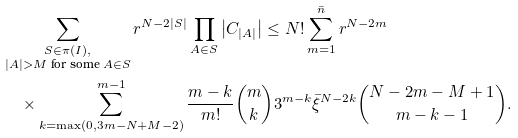Convert formula to latex. <formula><loc_0><loc_0><loc_500><loc_500>& \sum _ { \substack { S \in \pi ( I ) , \\ | A | > M \text { for some } A \in S } } r ^ { N - 2 | S | } \prod _ { A \in S } \left | C _ { | A | } \right | \leq N ! \sum _ { m = 1 } ^ { \bar { n } } r ^ { N - 2 m } \\ & \quad \times \sum _ { k = \max ( 0 , 3 m - N + M - 2 ) } ^ { m - 1 } \frac { m - k } { m ! } \binom { m } { k } 3 ^ { m - k } \bar { \xi } ^ { N - 2 k } \binom { N - 2 m - M + 1 } { m - k - 1 } .</formula> 